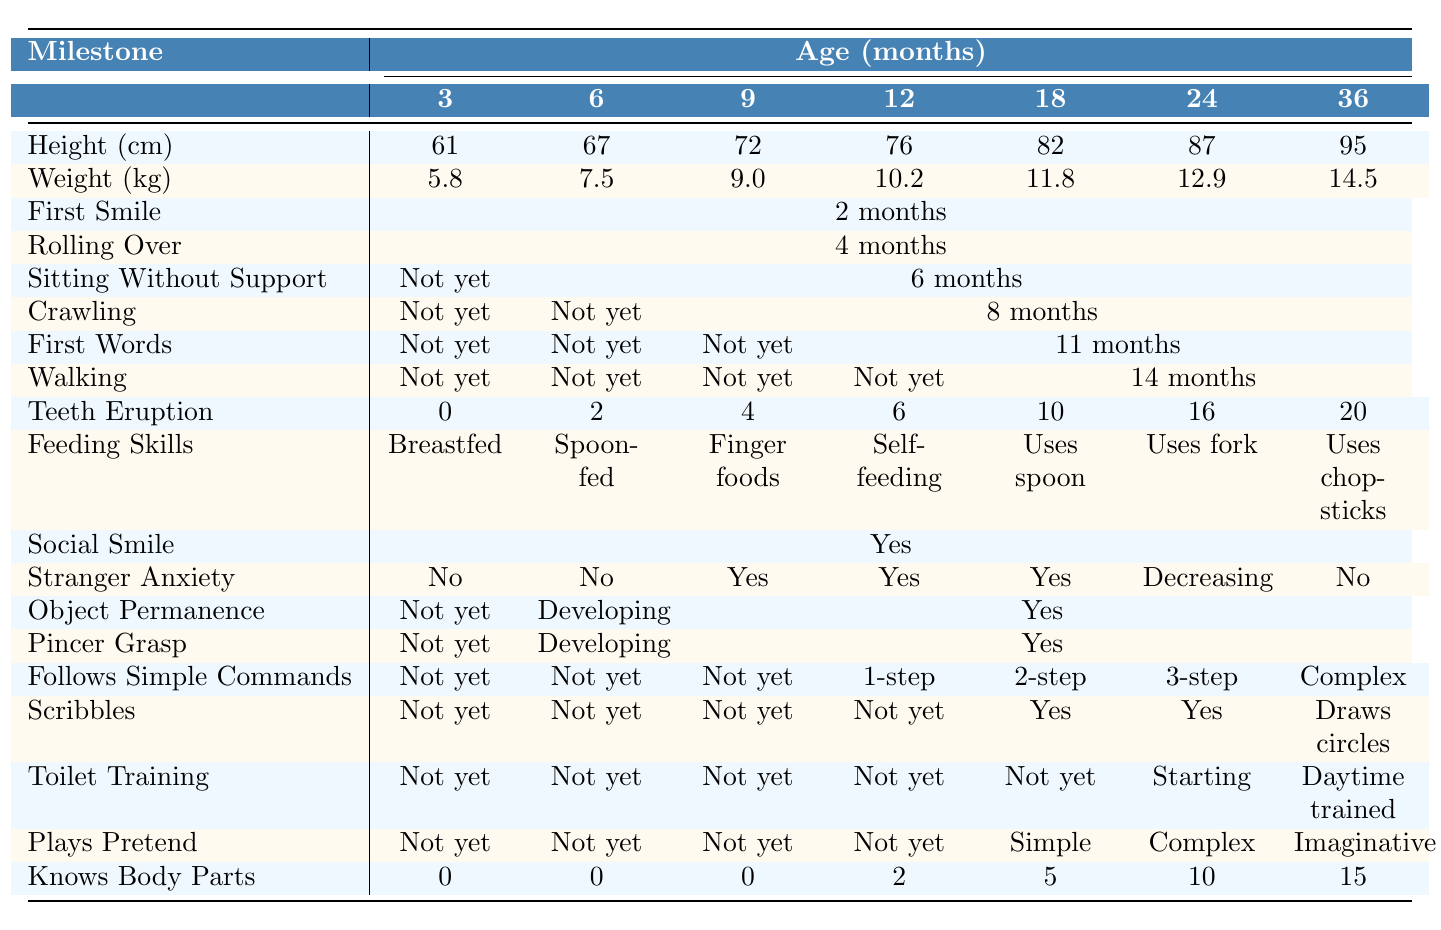What is M. Vignesh Kumar's weight at 12 months? The table shows that M. Vignesh Kumar's weight at 12 months is listed as 10.2 kg.
Answer: 10.2 kg At what age did M. Vignesh Kumar first achieve sitting without support? In the table, it's indicated that M. Vignesh Kumar started sitting without support at 6 months.
Answer: 6 months How many teeth did M. Vignesh Kumar have at 24 months? According to the table, M. Vignesh Kumar had 16 teeth at 24 months.
Answer: 16 teeth Was M. Vignesh Kumar able to crawl by 9 months? The table lists "8 months" for crawling achievement, meaning he was not yet crawling at 9 months.
Answer: No At what age did M. Vignesh Kumar first say his first words? The table shows that he said his first words at 11 months, as indicated in that row.
Answer: 11 months How much did M. Vignesh Kumar weigh at 36 months compared to when he was 24 months? The weight at 36 months is 14.5 kg and at 24 months is 12.9 kg. The difference is 14.5 kg - 12.9 kg = 1.6 kg.
Answer: 1.6 kg more Did M. Vignesh Kumar exhibit stranger anxiety at 18 months? The table indicates that he had stranger anxiety at 18 months, as it states "Yes" in that row.
Answer: Yes At which ages did M. Vignesh Kumar show a social smile? The table indicates that M. Vignesh Kumar had a social smile consistently at all ages listed in the table.
Answer: All ages What is the average number of body parts M. Vignesh Kumar knew by 36 months? To find the average for body parts known, we take the total at 36 months which is 15. As there's only one value at this age, the average is 15.
Answer: 15 At what age did M. Vignesh Kumar start toilet training? The table shows that toilet training started at 24 months as indicated in that row.
Answer: 24 months What milestones were achieved by M. Vignesh Kumar at 18 months? By 18 months, he had 82 cm in height, 11.8 kg in weight, was not yet independent in toilet training, and first words were said.
Answer: Height, weight, first words (not toilet trained) 